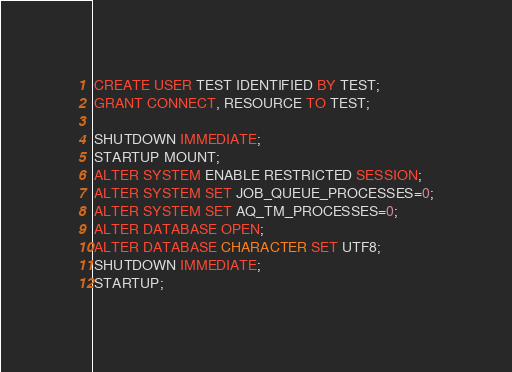Convert code to text. <code><loc_0><loc_0><loc_500><loc_500><_SQL_>CREATE USER TEST IDENTIFIED BY TEST;
GRANT CONNECT, RESOURCE TO TEST;

SHUTDOWN IMMEDIATE;
STARTUP MOUNT;
ALTER SYSTEM ENABLE RESTRICTED SESSION;
ALTER SYSTEM SET JOB_QUEUE_PROCESSES=0;
ALTER SYSTEM SET AQ_TM_PROCESSES=0;
ALTER DATABASE OPEN;
ALTER DATABASE CHARACTER SET UTF8;
SHUTDOWN IMMEDIATE;
STARTUP;
</code> 